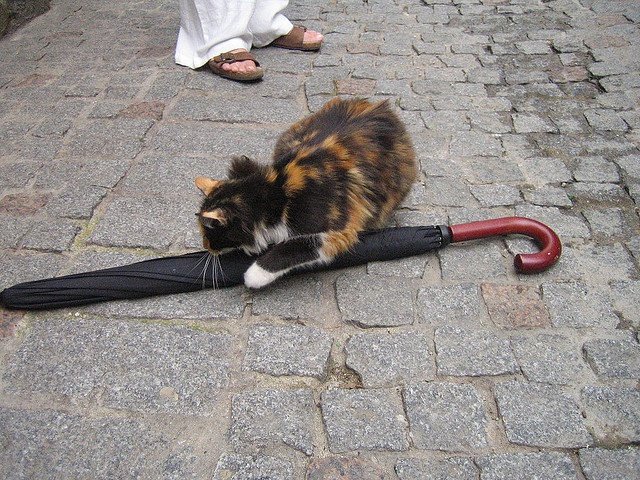Describe the objects in this image and their specific colors. I can see cat in darkgreen, black, gray, and maroon tones, umbrella in darkgreen, black, gray, and maroon tones, and people in darkgreen, lightgray, darkgray, gray, and black tones in this image. 